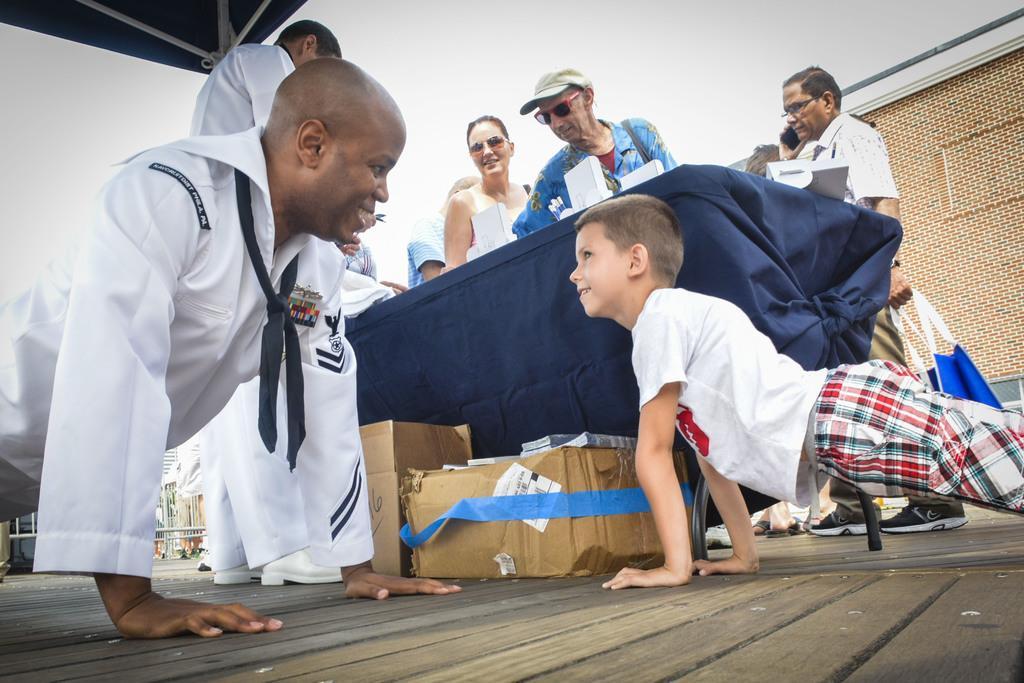In one or two sentences, can you explain what this image depicts? In this picture there is a navy officer wearing white dress and lying on the ground, smiling and looking to the boy. On the right side there is a boy wearing white t-shirt, is smiling and looking to him. In the background there is a table and a old man wearing a blue color shirt and standing. In the background we can see of brown color house wall. 